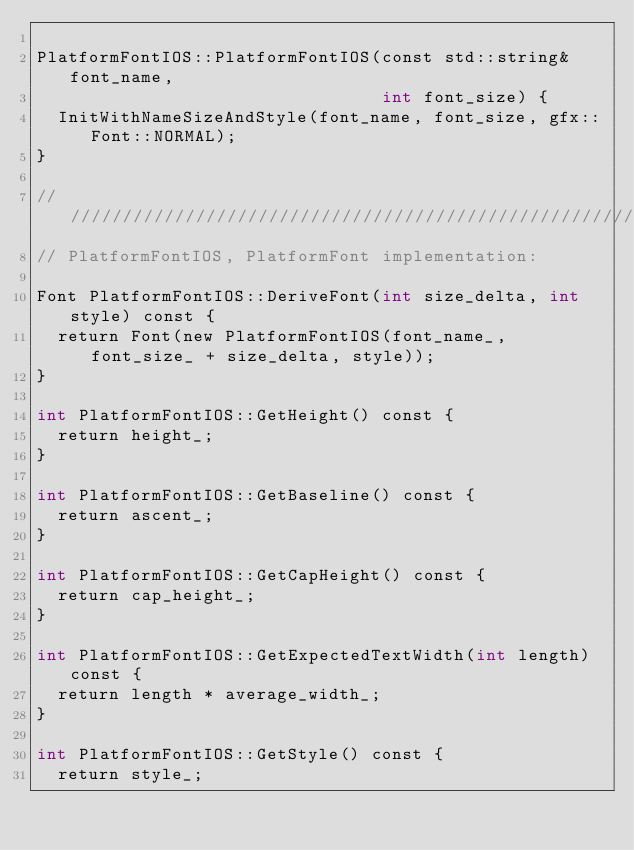<code> <loc_0><loc_0><loc_500><loc_500><_ObjectiveC_>
PlatformFontIOS::PlatformFontIOS(const std::string& font_name,
                                 int font_size) {
  InitWithNameSizeAndStyle(font_name, font_size, gfx::Font::NORMAL);
}

////////////////////////////////////////////////////////////////////////////////
// PlatformFontIOS, PlatformFont implementation:

Font PlatformFontIOS::DeriveFont(int size_delta, int style) const {
  return Font(new PlatformFontIOS(font_name_, font_size_ + size_delta, style));
}

int PlatformFontIOS::GetHeight() const {
  return height_;
}

int PlatformFontIOS::GetBaseline() const {
  return ascent_;
}

int PlatformFontIOS::GetCapHeight() const {
  return cap_height_;
}

int PlatformFontIOS::GetExpectedTextWidth(int length) const {
  return length * average_width_;
}

int PlatformFontIOS::GetStyle() const {
  return style_;</code> 